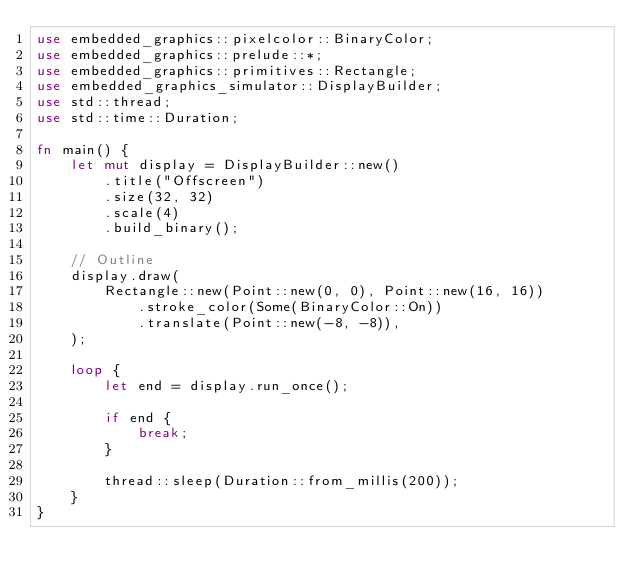Convert code to text. <code><loc_0><loc_0><loc_500><loc_500><_Rust_>use embedded_graphics::pixelcolor::BinaryColor;
use embedded_graphics::prelude::*;
use embedded_graphics::primitives::Rectangle;
use embedded_graphics_simulator::DisplayBuilder;
use std::thread;
use std::time::Duration;

fn main() {
    let mut display = DisplayBuilder::new()
        .title("Offscreen")
        .size(32, 32)
        .scale(4)
        .build_binary();

    // Outline
    display.draw(
        Rectangle::new(Point::new(0, 0), Point::new(16, 16))
            .stroke_color(Some(BinaryColor::On))
            .translate(Point::new(-8, -8)),
    );

    loop {
        let end = display.run_once();

        if end {
            break;
        }

        thread::sleep(Duration::from_millis(200));
    }
}
</code> 